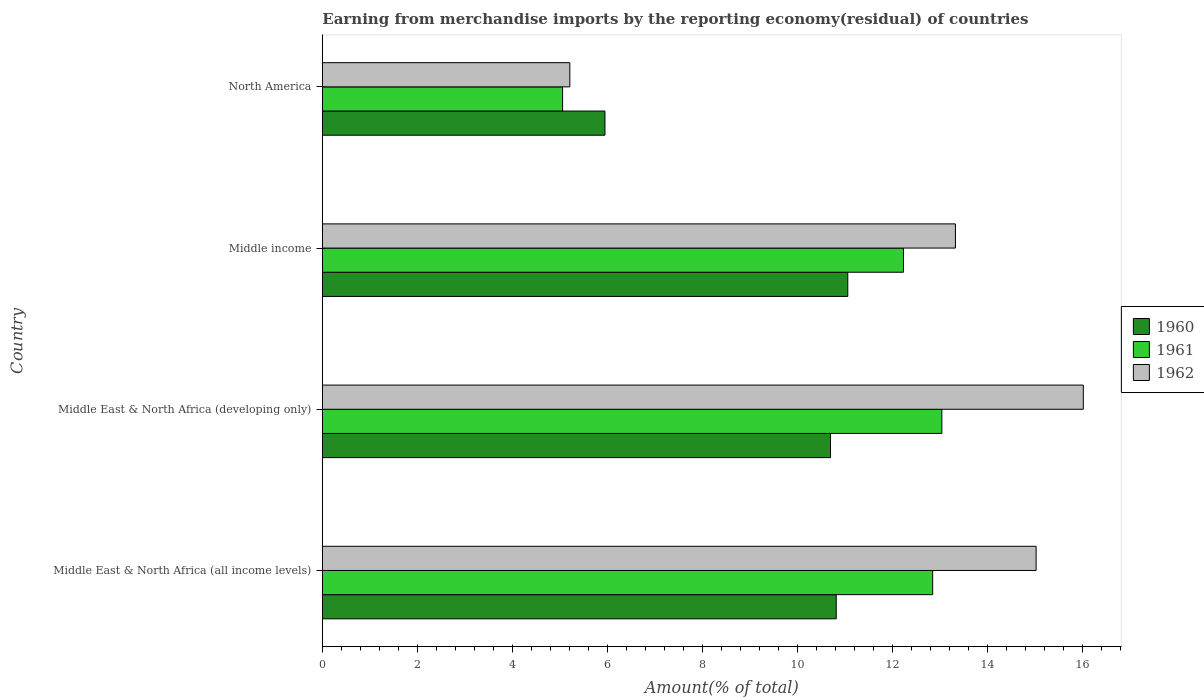Are the number of bars on each tick of the Y-axis equal?
Your answer should be compact. Yes. How many bars are there on the 2nd tick from the top?
Your answer should be compact. 3. How many bars are there on the 4th tick from the bottom?
Make the answer very short. 3. What is the label of the 3rd group of bars from the top?
Keep it short and to the point. Middle East & North Africa (developing only). In how many cases, is the number of bars for a given country not equal to the number of legend labels?
Your answer should be very brief. 0. What is the percentage of amount earned from merchandise imports in 1960 in North America?
Keep it short and to the point. 5.95. Across all countries, what is the maximum percentage of amount earned from merchandise imports in 1962?
Provide a short and direct response. 16.02. Across all countries, what is the minimum percentage of amount earned from merchandise imports in 1962?
Provide a short and direct response. 5.21. In which country was the percentage of amount earned from merchandise imports in 1961 maximum?
Your answer should be very brief. Middle East & North Africa (developing only). In which country was the percentage of amount earned from merchandise imports in 1962 minimum?
Offer a terse response. North America. What is the total percentage of amount earned from merchandise imports in 1962 in the graph?
Offer a very short reply. 49.58. What is the difference between the percentage of amount earned from merchandise imports in 1961 in Middle East & North Africa (developing only) and that in North America?
Ensure brevity in your answer.  7.98. What is the difference between the percentage of amount earned from merchandise imports in 1961 in Middle income and the percentage of amount earned from merchandise imports in 1960 in Middle East & North Africa (developing only)?
Ensure brevity in your answer.  1.54. What is the average percentage of amount earned from merchandise imports in 1961 per country?
Offer a terse response. 10.79. What is the difference between the percentage of amount earned from merchandise imports in 1960 and percentage of amount earned from merchandise imports in 1962 in Middle East & North Africa (all income levels)?
Your answer should be compact. -4.21. What is the ratio of the percentage of amount earned from merchandise imports in 1961 in Middle East & North Africa (all income levels) to that in Middle income?
Provide a succinct answer. 1.05. Is the percentage of amount earned from merchandise imports in 1960 in Middle income less than that in North America?
Offer a very short reply. No. What is the difference between the highest and the second highest percentage of amount earned from merchandise imports in 1962?
Your answer should be compact. 0.99. What is the difference between the highest and the lowest percentage of amount earned from merchandise imports in 1962?
Offer a terse response. 10.81. Is the sum of the percentage of amount earned from merchandise imports in 1960 in Middle income and North America greater than the maximum percentage of amount earned from merchandise imports in 1962 across all countries?
Your response must be concise. Yes. What does the 2nd bar from the top in Middle East & North Africa (all income levels) represents?
Provide a succinct answer. 1961. How many bars are there?
Your response must be concise. 12. Are all the bars in the graph horizontal?
Give a very brief answer. Yes. What is the difference between two consecutive major ticks on the X-axis?
Offer a terse response. 2. Does the graph contain grids?
Offer a terse response. No. How many legend labels are there?
Your response must be concise. 3. How are the legend labels stacked?
Provide a short and direct response. Vertical. What is the title of the graph?
Your response must be concise. Earning from merchandise imports by the reporting economy(residual) of countries. Does "1986" appear as one of the legend labels in the graph?
Ensure brevity in your answer.  No. What is the label or title of the X-axis?
Make the answer very short. Amount(% of total). What is the label or title of the Y-axis?
Offer a very short reply. Country. What is the Amount(% of total) in 1960 in Middle East & North Africa (all income levels)?
Ensure brevity in your answer.  10.82. What is the Amount(% of total) in 1961 in Middle East & North Africa (all income levels)?
Ensure brevity in your answer.  12.85. What is the Amount(% of total) in 1962 in Middle East & North Africa (all income levels)?
Provide a short and direct response. 15.03. What is the Amount(% of total) in 1960 in Middle East & North Africa (developing only)?
Give a very brief answer. 10.7. What is the Amount(% of total) in 1961 in Middle East & North Africa (developing only)?
Your answer should be compact. 13.04. What is the Amount(% of total) in 1962 in Middle East & North Africa (developing only)?
Provide a short and direct response. 16.02. What is the Amount(% of total) in 1960 in Middle income?
Offer a very short reply. 11.06. What is the Amount(% of total) in 1961 in Middle income?
Make the answer very short. 12.23. What is the Amount(% of total) in 1962 in Middle income?
Your response must be concise. 13.33. What is the Amount(% of total) of 1960 in North America?
Your answer should be very brief. 5.95. What is the Amount(% of total) in 1961 in North America?
Provide a succinct answer. 5.06. What is the Amount(% of total) in 1962 in North America?
Your response must be concise. 5.21. Across all countries, what is the maximum Amount(% of total) of 1960?
Give a very brief answer. 11.06. Across all countries, what is the maximum Amount(% of total) of 1961?
Offer a terse response. 13.04. Across all countries, what is the maximum Amount(% of total) of 1962?
Your response must be concise. 16.02. Across all countries, what is the minimum Amount(% of total) of 1960?
Your answer should be compact. 5.95. Across all countries, what is the minimum Amount(% of total) in 1961?
Ensure brevity in your answer.  5.06. Across all countries, what is the minimum Amount(% of total) of 1962?
Your response must be concise. 5.21. What is the total Amount(% of total) in 1960 in the graph?
Your answer should be very brief. 38.52. What is the total Amount(% of total) of 1961 in the graph?
Offer a terse response. 43.18. What is the total Amount(% of total) of 1962 in the graph?
Give a very brief answer. 49.58. What is the difference between the Amount(% of total) in 1960 in Middle East & North Africa (all income levels) and that in Middle East & North Africa (developing only)?
Your response must be concise. 0.12. What is the difference between the Amount(% of total) in 1961 in Middle East & North Africa (all income levels) and that in Middle East & North Africa (developing only)?
Ensure brevity in your answer.  -0.19. What is the difference between the Amount(% of total) of 1962 in Middle East & North Africa (all income levels) and that in Middle East & North Africa (developing only)?
Offer a very short reply. -0.99. What is the difference between the Amount(% of total) in 1960 in Middle East & North Africa (all income levels) and that in Middle income?
Offer a terse response. -0.24. What is the difference between the Amount(% of total) of 1961 in Middle East & North Africa (all income levels) and that in Middle income?
Your response must be concise. 0.62. What is the difference between the Amount(% of total) in 1962 in Middle East & North Africa (all income levels) and that in Middle income?
Make the answer very short. 1.7. What is the difference between the Amount(% of total) of 1960 in Middle East & North Africa (all income levels) and that in North America?
Offer a very short reply. 4.87. What is the difference between the Amount(% of total) of 1961 in Middle East & North Africa (all income levels) and that in North America?
Give a very brief answer. 7.79. What is the difference between the Amount(% of total) in 1962 in Middle East & North Africa (all income levels) and that in North America?
Provide a short and direct response. 9.82. What is the difference between the Amount(% of total) in 1960 in Middle East & North Africa (developing only) and that in Middle income?
Give a very brief answer. -0.36. What is the difference between the Amount(% of total) in 1961 in Middle East & North Africa (developing only) and that in Middle income?
Make the answer very short. 0.81. What is the difference between the Amount(% of total) in 1962 in Middle East & North Africa (developing only) and that in Middle income?
Your answer should be compact. 2.69. What is the difference between the Amount(% of total) of 1960 in Middle East & North Africa (developing only) and that in North America?
Keep it short and to the point. 4.75. What is the difference between the Amount(% of total) in 1961 in Middle East & North Africa (developing only) and that in North America?
Provide a short and direct response. 7.98. What is the difference between the Amount(% of total) in 1962 in Middle East & North Africa (developing only) and that in North America?
Provide a succinct answer. 10.81. What is the difference between the Amount(% of total) in 1960 in Middle income and that in North America?
Provide a succinct answer. 5.11. What is the difference between the Amount(% of total) of 1961 in Middle income and that in North America?
Offer a very short reply. 7.17. What is the difference between the Amount(% of total) in 1962 in Middle income and that in North America?
Make the answer very short. 8.12. What is the difference between the Amount(% of total) in 1960 in Middle East & North Africa (all income levels) and the Amount(% of total) in 1961 in Middle East & North Africa (developing only)?
Provide a succinct answer. -2.22. What is the difference between the Amount(% of total) of 1960 in Middle East & North Africa (all income levels) and the Amount(% of total) of 1962 in Middle East & North Africa (developing only)?
Ensure brevity in your answer.  -5.2. What is the difference between the Amount(% of total) of 1961 in Middle East & North Africa (all income levels) and the Amount(% of total) of 1962 in Middle East & North Africa (developing only)?
Offer a terse response. -3.17. What is the difference between the Amount(% of total) of 1960 in Middle East & North Africa (all income levels) and the Amount(% of total) of 1961 in Middle income?
Keep it short and to the point. -1.41. What is the difference between the Amount(% of total) of 1960 in Middle East & North Africa (all income levels) and the Amount(% of total) of 1962 in Middle income?
Make the answer very short. -2.51. What is the difference between the Amount(% of total) of 1961 in Middle East & North Africa (all income levels) and the Amount(% of total) of 1962 in Middle income?
Provide a short and direct response. -0.48. What is the difference between the Amount(% of total) in 1960 in Middle East & North Africa (all income levels) and the Amount(% of total) in 1961 in North America?
Keep it short and to the point. 5.76. What is the difference between the Amount(% of total) in 1960 in Middle East & North Africa (all income levels) and the Amount(% of total) in 1962 in North America?
Ensure brevity in your answer.  5.61. What is the difference between the Amount(% of total) of 1961 in Middle East & North Africa (all income levels) and the Amount(% of total) of 1962 in North America?
Your answer should be very brief. 7.64. What is the difference between the Amount(% of total) of 1960 in Middle East & North Africa (developing only) and the Amount(% of total) of 1961 in Middle income?
Give a very brief answer. -1.54. What is the difference between the Amount(% of total) of 1960 in Middle East & North Africa (developing only) and the Amount(% of total) of 1962 in Middle income?
Your response must be concise. -2.63. What is the difference between the Amount(% of total) in 1961 in Middle East & North Africa (developing only) and the Amount(% of total) in 1962 in Middle income?
Your response must be concise. -0.29. What is the difference between the Amount(% of total) of 1960 in Middle East & North Africa (developing only) and the Amount(% of total) of 1961 in North America?
Ensure brevity in your answer.  5.64. What is the difference between the Amount(% of total) in 1960 in Middle East & North Africa (developing only) and the Amount(% of total) in 1962 in North America?
Your response must be concise. 5.49. What is the difference between the Amount(% of total) in 1961 in Middle East & North Africa (developing only) and the Amount(% of total) in 1962 in North America?
Your answer should be compact. 7.83. What is the difference between the Amount(% of total) of 1960 in Middle income and the Amount(% of total) of 1961 in North America?
Your response must be concise. 6. What is the difference between the Amount(% of total) in 1960 in Middle income and the Amount(% of total) in 1962 in North America?
Your response must be concise. 5.85. What is the difference between the Amount(% of total) in 1961 in Middle income and the Amount(% of total) in 1962 in North America?
Make the answer very short. 7.02. What is the average Amount(% of total) of 1960 per country?
Keep it short and to the point. 9.63. What is the average Amount(% of total) in 1961 per country?
Make the answer very short. 10.79. What is the average Amount(% of total) in 1962 per country?
Keep it short and to the point. 12.4. What is the difference between the Amount(% of total) of 1960 and Amount(% of total) of 1961 in Middle East & North Africa (all income levels)?
Your answer should be very brief. -2.03. What is the difference between the Amount(% of total) in 1960 and Amount(% of total) in 1962 in Middle East & North Africa (all income levels)?
Ensure brevity in your answer.  -4.21. What is the difference between the Amount(% of total) in 1961 and Amount(% of total) in 1962 in Middle East & North Africa (all income levels)?
Give a very brief answer. -2.18. What is the difference between the Amount(% of total) in 1960 and Amount(% of total) in 1961 in Middle East & North Africa (developing only)?
Your response must be concise. -2.34. What is the difference between the Amount(% of total) in 1960 and Amount(% of total) in 1962 in Middle East & North Africa (developing only)?
Provide a succinct answer. -5.32. What is the difference between the Amount(% of total) of 1961 and Amount(% of total) of 1962 in Middle East & North Africa (developing only)?
Your response must be concise. -2.98. What is the difference between the Amount(% of total) in 1960 and Amount(% of total) in 1961 in Middle income?
Ensure brevity in your answer.  -1.17. What is the difference between the Amount(% of total) of 1960 and Amount(% of total) of 1962 in Middle income?
Make the answer very short. -2.27. What is the difference between the Amount(% of total) in 1961 and Amount(% of total) in 1962 in Middle income?
Offer a terse response. -1.09. What is the difference between the Amount(% of total) of 1960 and Amount(% of total) of 1961 in North America?
Your answer should be compact. 0.89. What is the difference between the Amount(% of total) of 1960 and Amount(% of total) of 1962 in North America?
Give a very brief answer. 0.74. What is the difference between the Amount(% of total) in 1961 and Amount(% of total) in 1962 in North America?
Provide a short and direct response. -0.15. What is the ratio of the Amount(% of total) of 1960 in Middle East & North Africa (all income levels) to that in Middle East & North Africa (developing only)?
Ensure brevity in your answer.  1.01. What is the ratio of the Amount(% of total) of 1961 in Middle East & North Africa (all income levels) to that in Middle East & North Africa (developing only)?
Make the answer very short. 0.99. What is the ratio of the Amount(% of total) of 1962 in Middle East & North Africa (all income levels) to that in Middle East & North Africa (developing only)?
Make the answer very short. 0.94. What is the ratio of the Amount(% of total) of 1961 in Middle East & North Africa (all income levels) to that in Middle income?
Ensure brevity in your answer.  1.05. What is the ratio of the Amount(% of total) of 1962 in Middle East & North Africa (all income levels) to that in Middle income?
Make the answer very short. 1.13. What is the ratio of the Amount(% of total) in 1960 in Middle East & North Africa (all income levels) to that in North America?
Make the answer very short. 1.82. What is the ratio of the Amount(% of total) in 1961 in Middle East & North Africa (all income levels) to that in North America?
Your answer should be very brief. 2.54. What is the ratio of the Amount(% of total) in 1962 in Middle East & North Africa (all income levels) to that in North America?
Your answer should be compact. 2.88. What is the ratio of the Amount(% of total) of 1960 in Middle East & North Africa (developing only) to that in Middle income?
Keep it short and to the point. 0.97. What is the ratio of the Amount(% of total) of 1961 in Middle East & North Africa (developing only) to that in Middle income?
Make the answer very short. 1.07. What is the ratio of the Amount(% of total) of 1962 in Middle East & North Africa (developing only) to that in Middle income?
Your response must be concise. 1.2. What is the ratio of the Amount(% of total) in 1960 in Middle East & North Africa (developing only) to that in North America?
Provide a short and direct response. 1.8. What is the ratio of the Amount(% of total) in 1961 in Middle East & North Africa (developing only) to that in North America?
Your response must be concise. 2.58. What is the ratio of the Amount(% of total) of 1962 in Middle East & North Africa (developing only) to that in North America?
Offer a terse response. 3.07. What is the ratio of the Amount(% of total) in 1960 in Middle income to that in North America?
Your answer should be compact. 1.86. What is the ratio of the Amount(% of total) of 1961 in Middle income to that in North America?
Your response must be concise. 2.42. What is the ratio of the Amount(% of total) in 1962 in Middle income to that in North America?
Provide a succinct answer. 2.56. What is the difference between the highest and the second highest Amount(% of total) of 1960?
Your answer should be compact. 0.24. What is the difference between the highest and the second highest Amount(% of total) of 1961?
Give a very brief answer. 0.19. What is the difference between the highest and the second highest Amount(% of total) in 1962?
Offer a terse response. 0.99. What is the difference between the highest and the lowest Amount(% of total) in 1960?
Your answer should be compact. 5.11. What is the difference between the highest and the lowest Amount(% of total) in 1961?
Ensure brevity in your answer.  7.98. What is the difference between the highest and the lowest Amount(% of total) of 1962?
Provide a succinct answer. 10.81. 